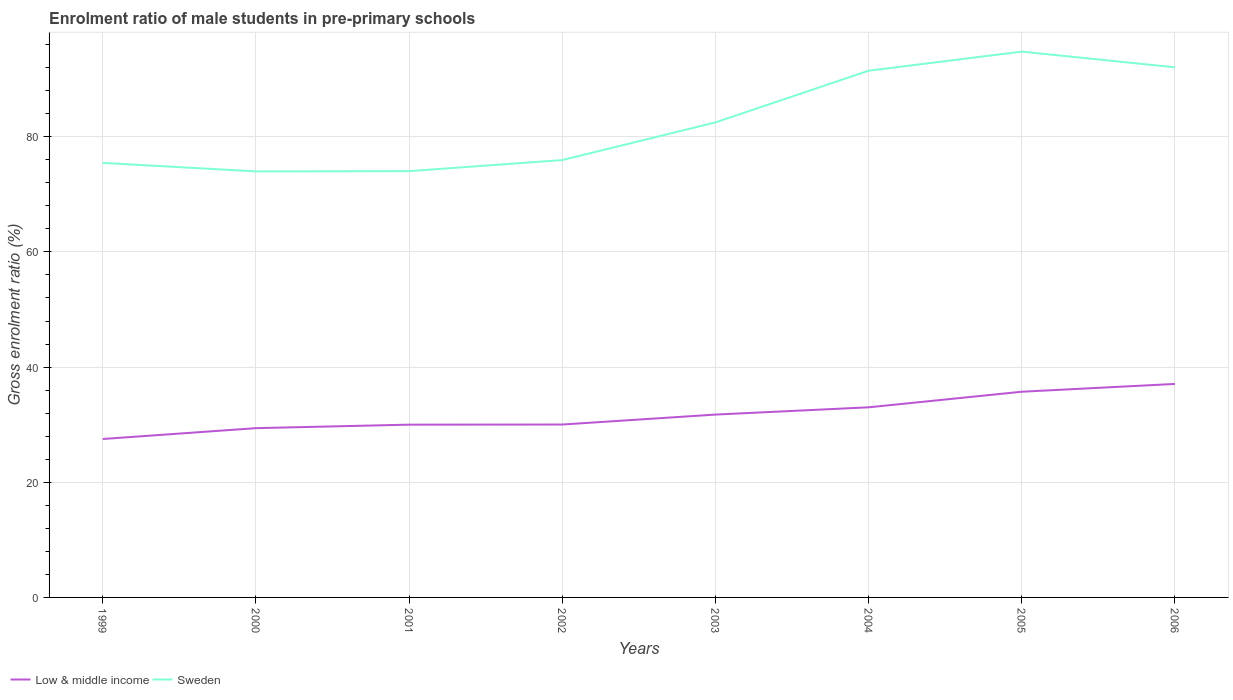Does the line corresponding to Sweden intersect with the line corresponding to Low & middle income?
Offer a terse response. No. Is the number of lines equal to the number of legend labels?
Offer a very short reply. Yes. Across all years, what is the maximum enrolment ratio of male students in pre-primary schools in Low & middle income?
Offer a very short reply. 27.51. What is the total enrolment ratio of male students in pre-primary schools in Low & middle income in the graph?
Your answer should be compact. -5.72. What is the difference between the highest and the second highest enrolment ratio of male students in pre-primary schools in Sweden?
Provide a succinct answer. 20.8. What is the difference between the highest and the lowest enrolment ratio of male students in pre-primary schools in Sweden?
Offer a terse response. 3. Is the enrolment ratio of male students in pre-primary schools in Low & middle income strictly greater than the enrolment ratio of male students in pre-primary schools in Sweden over the years?
Keep it short and to the point. Yes. How many lines are there?
Keep it short and to the point. 2. Are the values on the major ticks of Y-axis written in scientific E-notation?
Ensure brevity in your answer.  No. Does the graph contain any zero values?
Ensure brevity in your answer.  No. Does the graph contain grids?
Your answer should be very brief. Yes. Where does the legend appear in the graph?
Your answer should be very brief. Bottom left. How many legend labels are there?
Make the answer very short. 2. What is the title of the graph?
Provide a short and direct response. Enrolment ratio of male students in pre-primary schools. Does "Japan" appear as one of the legend labels in the graph?
Offer a terse response. No. What is the label or title of the X-axis?
Your answer should be very brief. Years. What is the label or title of the Y-axis?
Offer a terse response. Gross enrolment ratio (%). What is the Gross enrolment ratio (%) in Low & middle income in 1999?
Make the answer very short. 27.51. What is the Gross enrolment ratio (%) in Sweden in 1999?
Your answer should be very brief. 75.46. What is the Gross enrolment ratio (%) of Low & middle income in 2000?
Provide a succinct answer. 29.39. What is the Gross enrolment ratio (%) of Sweden in 2000?
Provide a short and direct response. 73.99. What is the Gross enrolment ratio (%) in Low & middle income in 2001?
Your answer should be compact. 30. What is the Gross enrolment ratio (%) in Sweden in 2001?
Provide a short and direct response. 74.02. What is the Gross enrolment ratio (%) of Low & middle income in 2002?
Give a very brief answer. 30.02. What is the Gross enrolment ratio (%) in Sweden in 2002?
Keep it short and to the point. 75.95. What is the Gross enrolment ratio (%) in Low & middle income in 2003?
Offer a very short reply. 31.75. What is the Gross enrolment ratio (%) of Sweden in 2003?
Your answer should be very brief. 82.49. What is the Gross enrolment ratio (%) of Low & middle income in 2004?
Make the answer very short. 33.01. What is the Gross enrolment ratio (%) of Sweden in 2004?
Your answer should be very brief. 91.47. What is the Gross enrolment ratio (%) in Low & middle income in 2005?
Your answer should be very brief. 35.72. What is the Gross enrolment ratio (%) in Sweden in 2005?
Keep it short and to the point. 94.78. What is the Gross enrolment ratio (%) of Low & middle income in 2006?
Give a very brief answer. 37.07. What is the Gross enrolment ratio (%) in Sweden in 2006?
Your response must be concise. 92.06. Across all years, what is the maximum Gross enrolment ratio (%) in Low & middle income?
Your answer should be very brief. 37.07. Across all years, what is the maximum Gross enrolment ratio (%) in Sweden?
Keep it short and to the point. 94.78. Across all years, what is the minimum Gross enrolment ratio (%) of Low & middle income?
Offer a terse response. 27.51. Across all years, what is the minimum Gross enrolment ratio (%) in Sweden?
Offer a terse response. 73.99. What is the total Gross enrolment ratio (%) in Low & middle income in the graph?
Provide a succinct answer. 254.49. What is the total Gross enrolment ratio (%) in Sweden in the graph?
Provide a succinct answer. 660.22. What is the difference between the Gross enrolment ratio (%) of Low & middle income in 1999 and that in 2000?
Offer a terse response. -1.88. What is the difference between the Gross enrolment ratio (%) in Sweden in 1999 and that in 2000?
Ensure brevity in your answer.  1.47. What is the difference between the Gross enrolment ratio (%) of Low & middle income in 1999 and that in 2001?
Make the answer very short. -2.49. What is the difference between the Gross enrolment ratio (%) of Sweden in 1999 and that in 2001?
Your response must be concise. 1.43. What is the difference between the Gross enrolment ratio (%) of Low & middle income in 1999 and that in 2002?
Provide a short and direct response. -2.51. What is the difference between the Gross enrolment ratio (%) of Sweden in 1999 and that in 2002?
Offer a very short reply. -0.49. What is the difference between the Gross enrolment ratio (%) in Low & middle income in 1999 and that in 2003?
Your answer should be compact. -4.24. What is the difference between the Gross enrolment ratio (%) of Sweden in 1999 and that in 2003?
Ensure brevity in your answer.  -7.03. What is the difference between the Gross enrolment ratio (%) of Low & middle income in 1999 and that in 2004?
Your answer should be compact. -5.5. What is the difference between the Gross enrolment ratio (%) in Sweden in 1999 and that in 2004?
Make the answer very short. -16.01. What is the difference between the Gross enrolment ratio (%) in Low & middle income in 1999 and that in 2005?
Your answer should be compact. -8.21. What is the difference between the Gross enrolment ratio (%) of Sweden in 1999 and that in 2005?
Give a very brief answer. -19.33. What is the difference between the Gross enrolment ratio (%) of Low & middle income in 1999 and that in 2006?
Your answer should be very brief. -9.56. What is the difference between the Gross enrolment ratio (%) of Sweden in 1999 and that in 2006?
Your response must be concise. -16.6. What is the difference between the Gross enrolment ratio (%) of Low & middle income in 2000 and that in 2001?
Ensure brevity in your answer.  -0.61. What is the difference between the Gross enrolment ratio (%) in Sweden in 2000 and that in 2001?
Your response must be concise. -0.04. What is the difference between the Gross enrolment ratio (%) in Low & middle income in 2000 and that in 2002?
Offer a very short reply. -0.63. What is the difference between the Gross enrolment ratio (%) in Sweden in 2000 and that in 2002?
Your response must be concise. -1.97. What is the difference between the Gross enrolment ratio (%) of Low & middle income in 2000 and that in 2003?
Your answer should be compact. -2.36. What is the difference between the Gross enrolment ratio (%) of Sweden in 2000 and that in 2003?
Your answer should be very brief. -8.5. What is the difference between the Gross enrolment ratio (%) in Low & middle income in 2000 and that in 2004?
Provide a short and direct response. -3.62. What is the difference between the Gross enrolment ratio (%) of Sweden in 2000 and that in 2004?
Provide a short and direct response. -17.48. What is the difference between the Gross enrolment ratio (%) in Low & middle income in 2000 and that in 2005?
Make the answer very short. -6.33. What is the difference between the Gross enrolment ratio (%) of Sweden in 2000 and that in 2005?
Provide a short and direct response. -20.8. What is the difference between the Gross enrolment ratio (%) in Low & middle income in 2000 and that in 2006?
Offer a terse response. -7.68. What is the difference between the Gross enrolment ratio (%) in Sweden in 2000 and that in 2006?
Give a very brief answer. -18.07. What is the difference between the Gross enrolment ratio (%) of Low & middle income in 2001 and that in 2002?
Provide a succinct answer. -0.02. What is the difference between the Gross enrolment ratio (%) of Sweden in 2001 and that in 2002?
Keep it short and to the point. -1.93. What is the difference between the Gross enrolment ratio (%) in Low & middle income in 2001 and that in 2003?
Offer a terse response. -1.75. What is the difference between the Gross enrolment ratio (%) in Sweden in 2001 and that in 2003?
Provide a short and direct response. -8.46. What is the difference between the Gross enrolment ratio (%) in Low & middle income in 2001 and that in 2004?
Provide a succinct answer. -3.01. What is the difference between the Gross enrolment ratio (%) in Sweden in 2001 and that in 2004?
Your answer should be compact. -17.44. What is the difference between the Gross enrolment ratio (%) of Low & middle income in 2001 and that in 2005?
Make the answer very short. -5.72. What is the difference between the Gross enrolment ratio (%) in Sweden in 2001 and that in 2005?
Offer a very short reply. -20.76. What is the difference between the Gross enrolment ratio (%) of Low & middle income in 2001 and that in 2006?
Your answer should be compact. -7.07. What is the difference between the Gross enrolment ratio (%) of Sweden in 2001 and that in 2006?
Your answer should be compact. -18.03. What is the difference between the Gross enrolment ratio (%) of Low & middle income in 2002 and that in 2003?
Provide a short and direct response. -1.73. What is the difference between the Gross enrolment ratio (%) in Sweden in 2002 and that in 2003?
Provide a succinct answer. -6.54. What is the difference between the Gross enrolment ratio (%) in Low & middle income in 2002 and that in 2004?
Offer a terse response. -2.99. What is the difference between the Gross enrolment ratio (%) in Sweden in 2002 and that in 2004?
Offer a very short reply. -15.51. What is the difference between the Gross enrolment ratio (%) of Low & middle income in 2002 and that in 2005?
Ensure brevity in your answer.  -5.7. What is the difference between the Gross enrolment ratio (%) in Sweden in 2002 and that in 2005?
Give a very brief answer. -18.83. What is the difference between the Gross enrolment ratio (%) in Low & middle income in 2002 and that in 2006?
Your answer should be very brief. -7.05. What is the difference between the Gross enrolment ratio (%) of Sweden in 2002 and that in 2006?
Give a very brief answer. -16.11. What is the difference between the Gross enrolment ratio (%) of Low & middle income in 2003 and that in 2004?
Provide a succinct answer. -1.26. What is the difference between the Gross enrolment ratio (%) in Sweden in 2003 and that in 2004?
Give a very brief answer. -8.98. What is the difference between the Gross enrolment ratio (%) of Low & middle income in 2003 and that in 2005?
Keep it short and to the point. -3.97. What is the difference between the Gross enrolment ratio (%) of Sweden in 2003 and that in 2005?
Your answer should be compact. -12.29. What is the difference between the Gross enrolment ratio (%) in Low & middle income in 2003 and that in 2006?
Your answer should be very brief. -5.32. What is the difference between the Gross enrolment ratio (%) of Sweden in 2003 and that in 2006?
Make the answer very short. -9.57. What is the difference between the Gross enrolment ratio (%) of Low & middle income in 2004 and that in 2005?
Your answer should be compact. -2.71. What is the difference between the Gross enrolment ratio (%) in Sweden in 2004 and that in 2005?
Offer a very short reply. -3.32. What is the difference between the Gross enrolment ratio (%) of Low & middle income in 2004 and that in 2006?
Offer a terse response. -4.06. What is the difference between the Gross enrolment ratio (%) of Sweden in 2004 and that in 2006?
Provide a succinct answer. -0.59. What is the difference between the Gross enrolment ratio (%) in Low & middle income in 2005 and that in 2006?
Keep it short and to the point. -1.35. What is the difference between the Gross enrolment ratio (%) in Sweden in 2005 and that in 2006?
Offer a terse response. 2.72. What is the difference between the Gross enrolment ratio (%) in Low & middle income in 1999 and the Gross enrolment ratio (%) in Sweden in 2000?
Provide a short and direct response. -46.48. What is the difference between the Gross enrolment ratio (%) in Low & middle income in 1999 and the Gross enrolment ratio (%) in Sweden in 2001?
Your response must be concise. -46.51. What is the difference between the Gross enrolment ratio (%) in Low & middle income in 1999 and the Gross enrolment ratio (%) in Sweden in 2002?
Your response must be concise. -48.44. What is the difference between the Gross enrolment ratio (%) in Low & middle income in 1999 and the Gross enrolment ratio (%) in Sweden in 2003?
Ensure brevity in your answer.  -54.98. What is the difference between the Gross enrolment ratio (%) in Low & middle income in 1999 and the Gross enrolment ratio (%) in Sweden in 2004?
Provide a succinct answer. -63.95. What is the difference between the Gross enrolment ratio (%) in Low & middle income in 1999 and the Gross enrolment ratio (%) in Sweden in 2005?
Offer a terse response. -67.27. What is the difference between the Gross enrolment ratio (%) in Low & middle income in 1999 and the Gross enrolment ratio (%) in Sweden in 2006?
Ensure brevity in your answer.  -64.55. What is the difference between the Gross enrolment ratio (%) of Low & middle income in 2000 and the Gross enrolment ratio (%) of Sweden in 2001?
Your answer should be very brief. -44.63. What is the difference between the Gross enrolment ratio (%) of Low & middle income in 2000 and the Gross enrolment ratio (%) of Sweden in 2002?
Your answer should be very brief. -46.56. What is the difference between the Gross enrolment ratio (%) of Low & middle income in 2000 and the Gross enrolment ratio (%) of Sweden in 2003?
Ensure brevity in your answer.  -53.09. What is the difference between the Gross enrolment ratio (%) of Low & middle income in 2000 and the Gross enrolment ratio (%) of Sweden in 2004?
Your answer should be compact. -62.07. What is the difference between the Gross enrolment ratio (%) of Low & middle income in 2000 and the Gross enrolment ratio (%) of Sweden in 2005?
Ensure brevity in your answer.  -65.39. What is the difference between the Gross enrolment ratio (%) in Low & middle income in 2000 and the Gross enrolment ratio (%) in Sweden in 2006?
Provide a short and direct response. -62.66. What is the difference between the Gross enrolment ratio (%) in Low & middle income in 2001 and the Gross enrolment ratio (%) in Sweden in 2002?
Offer a terse response. -45.95. What is the difference between the Gross enrolment ratio (%) in Low & middle income in 2001 and the Gross enrolment ratio (%) in Sweden in 2003?
Your answer should be compact. -52.49. What is the difference between the Gross enrolment ratio (%) of Low & middle income in 2001 and the Gross enrolment ratio (%) of Sweden in 2004?
Offer a very short reply. -61.46. What is the difference between the Gross enrolment ratio (%) in Low & middle income in 2001 and the Gross enrolment ratio (%) in Sweden in 2005?
Keep it short and to the point. -64.78. What is the difference between the Gross enrolment ratio (%) of Low & middle income in 2001 and the Gross enrolment ratio (%) of Sweden in 2006?
Offer a very short reply. -62.06. What is the difference between the Gross enrolment ratio (%) in Low & middle income in 2002 and the Gross enrolment ratio (%) in Sweden in 2003?
Your answer should be compact. -52.46. What is the difference between the Gross enrolment ratio (%) of Low & middle income in 2002 and the Gross enrolment ratio (%) of Sweden in 2004?
Your answer should be very brief. -61.44. What is the difference between the Gross enrolment ratio (%) in Low & middle income in 2002 and the Gross enrolment ratio (%) in Sweden in 2005?
Provide a short and direct response. -64.76. What is the difference between the Gross enrolment ratio (%) of Low & middle income in 2002 and the Gross enrolment ratio (%) of Sweden in 2006?
Provide a succinct answer. -62.04. What is the difference between the Gross enrolment ratio (%) in Low & middle income in 2003 and the Gross enrolment ratio (%) in Sweden in 2004?
Your response must be concise. -59.71. What is the difference between the Gross enrolment ratio (%) of Low & middle income in 2003 and the Gross enrolment ratio (%) of Sweden in 2005?
Offer a terse response. -63.03. What is the difference between the Gross enrolment ratio (%) in Low & middle income in 2003 and the Gross enrolment ratio (%) in Sweden in 2006?
Offer a terse response. -60.31. What is the difference between the Gross enrolment ratio (%) of Low & middle income in 2004 and the Gross enrolment ratio (%) of Sweden in 2005?
Provide a short and direct response. -61.77. What is the difference between the Gross enrolment ratio (%) in Low & middle income in 2004 and the Gross enrolment ratio (%) in Sweden in 2006?
Offer a very short reply. -59.05. What is the difference between the Gross enrolment ratio (%) of Low & middle income in 2005 and the Gross enrolment ratio (%) of Sweden in 2006?
Your response must be concise. -56.34. What is the average Gross enrolment ratio (%) of Low & middle income per year?
Keep it short and to the point. 31.81. What is the average Gross enrolment ratio (%) of Sweden per year?
Ensure brevity in your answer.  82.53. In the year 1999, what is the difference between the Gross enrolment ratio (%) of Low & middle income and Gross enrolment ratio (%) of Sweden?
Give a very brief answer. -47.95. In the year 2000, what is the difference between the Gross enrolment ratio (%) of Low & middle income and Gross enrolment ratio (%) of Sweden?
Your answer should be compact. -44.59. In the year 2001, what is the difference between the Gross enrolment ratio (%) in Low & middle income and Gross enrolment ratio (%) in Sweden?
Give a very brief answer. -44.02. In the year 2002, what is the difference between the Gross enrolment ratio (%) in Low & middle income and Gross enrolment ratio (%) in Sweden?
Provide a short and direct response. -45.93. In the year 2003, what is the difference between the Gross enrolment ratio (%) in Low & middle income and Gross enrolment ratio (%) in Sweden?
Provide a succinct answer. -50.74. In the year 2004, what is the difference between the Gross enrolment ratio (%) in Low & middle income and Gross enrolment ratio (%) in Sweden?
Make the answer very short. -58.45. In the year 2005, what is the difference between the Gross enrolment ratio (%) in Low & middle income and Gross enrolment ratio (%) in Sweden?
Make the answer very short. -59.06. In the year 2006, what is the difference between the Gross enrolment ratio (%) of Low & middle income and Gross enrolment ratio (%) of Sweden?
Make the answer very short. -54.99. What is the ratio of the Gross enrolment ratio (%) of Low & middle income in 1999 to that in 2000?
Keep it short and to the point. 0.94. What is the ratio of the Gross enrolment ratio (%) of Sweden in 1999 to that in 2000?
Your response must be concise. 1.02. What is the ratio of the Gross enrolment ratio (%) of Low & middle income in 1999 to that in 2001?
Offer a very short reply. 0.92. What is the ratio of the Gross enrolment ratio (%) in Sweden in 1999 to that in 2001?
Offer a very short reply. 1.02. What is the ratio of the Gross enrolment ratio (%) in Low & middle income in 1999 to that in 2002?
Your answer should be very brief. 0.92. What is the ratio of the Gross enrolment ratio (%) of Sweden in 1999 to that in 2002?
Provide a short and direct response. 0.99. What is the ratio of the Gross enrolment ratio (%) in Low & middle income in 1999 to that in 2003?
Ensure brevity in your answer.  0.87. What is the ratio of the Gross enrolment ratio (%) of Sweden in 1999 to that in 2003?
Your response must be concise. 0.91. What is the ratio of the Gross enrolment ratio (%) in Low & middle income in 1999 to that in 2004?
Give a very brief answer. 0.83. What is the ratio of the Gross enrolment ratio (%) of Sweden in 1999 to that in 2004?
Ensure brevity in your answer.  0.82. What is the ratio of the Gross enrolment ratio (%) of Low & middle income in 1999 to that in 2005?
Keep it short and to the point. 0.77. What is the ratio of the Gross enrolment ratio (%) in Sweden in 1999 to that in 2005?
Ensure brevity in your answer.  0.8. What is the ratio of the Gross enrolment ratio (%) of Low & middle income in 1999 to that in 2006?
Give a very brief answer. 0.74. What is the ratio of the Gross enrolment ratio (%) of Sweden in 1999 to that in 2006?
Keep it short and to the point. 0.82. What is the ratio of the Gross enrolment ratio (%) of Low & middle income in 2000 to that in 2001?
Provide a succinct answer. 0.98. What is the ratio of the Gross enrolment ratio (%) of Low & middle income in 2000 to that in 2002?
Offer a very short reply. 0.98. What is the ratio of the Gross enrolment ratio (%) of Sweden in 2000 to that in 2002?
Give a very brief answer. 0.97. What is the ratio of the Gross enrolment ratio (%) in Low & middle income in 2000 to that in 2003?
Provide a succinct answer. 0.93. What is the ratio of the Gross enrolment ratio (%) in Sweden in 2000 to that in 2003?
Provide a succinct answer. 0.9. What is the ratio of the Gross enrolment ratio (%) of Low & middle income in 2000 to that in 2004?
Ensure brevity in your answer.  0.89. What is the ratio of the Gross enrolment ratio (%) of Sweden in 2000 to that in 2004?
Your answer should be very brief. 0.81. What is the ratio of the Gross enrolment ratio (%) in Low & middle income in 2000 to that in 2005?
Offer a very short reply. 0.82. What is the ratio of the Gross enrolment ratio (%) of Sweden in 2000 to that in 2005?
Your answer should be compact. 0.78. What is the ratio of the Gross enrolment ratio (%) in Low & middle income in 2000 to that in 2006?
Your answer should be compact. 0.79. What is the ratio of the Gross enrolment ratio (%) of Sweden in 2000 to that in 2006?
Offer a terse response. 0.8. What is the ratio of the Gross enrolment ratio (%) in Sweden in 2001 to that in 2002?
Your answer should be very brief. 0.97. What is the ratio of the Gross enrolment ratio (%) of Low & middle income in 2001 to that in 2003?
Your response must be concise. 0.94. What is the ratio of the Gross enrolment ratio (%) of Sweden in 2001 to that in 2003?
Offer a terse response. 0.9. What is the ratio of the Gross enrolment ratio (%) of Low & middle income in 2001 to that in 2004?
Give a very brief answer. 0.91. What is the ratio of the Gross enrolment ratio (%) in Sweden in 2001 to that in 2004?
Your response must be concise. 0.81. What is the ratio of the Gross enrolment ratio (%) in Low & middle income in 2001 to that in 2005?
Your answer should be compact. 0.84. What is the ratio of the Gross enrolment ratio (%) of Sweden in 2001 to that in 2005?
Offer a very short reply. 0.78. What is the ratio of the Gross enrolment ratio (%) in Low & middle income in 2001 to that in 2006?
Your answer should be very brief. 0.81. What is the ratio of the Gross enrolment ratio (%) in Sweden in 2001 to that in 2006?
Make the answer very short. 0.8. What is the ratio of the Gross enrolment ratio (%) of Low & middle income in 2002 to that in 2003?
Offer a very short reply. 0.95. What is the ratio of the Gross enrolment ratio (%) of Sweden in 2002 to that in 2003?
Your answer should be compact. 0.92. What is the ratio of the Gross enrolment ratio (%) in Low & middle income in 2002 to that in 2004?
Your answer should be compact. 0.91. What is the ratio of the Gross enrolment ratio (%) of Sweden in 2002 to that in 2004?
Your answer should be compact. 0.83. What is the ratio of the Gross enrolment ratio (%) of Low & middle income in 2002 to that in 2005?
Offer a terse response. 0.84. What is the ratio of the Gross enrolment ratio (%) in Sweden in 2002 to that in 2005?
Keep it short and to the point. 0.8. What is the ratio of the Gross enrolment ratio (%) of Low & middle income in 2002 to that in 2006?
Give a very brief answer. 0.81. What is the ratio of the Gross enrolment ratio (%) in Sweden in 2002 to that in 2006?
Ensure brevity in your answer.  0.82. What is the ratio of the Gross enrolment ratio (%) in Low & middle income in 2003 to that in 2004?
Give a very brief answer. 0.96. What is the ratio of the Gross enrolment ratio (%) in Sweden in 2003 to that in 2004?
Give a very brief answer. 0.9. What is the ratio of the Gross enrolment ratio (%) of Sweden in 2003 to that in 2005?
Make the answer very short. 0.87. What is the ratio of the Gross enrolment ratio (%) of Low & middle income in 2003 to that in 2006?
Give a very brief answer. 0.86. What is the ratio of the Gross enrolment ratio (%) of Sweden in 2003 to that in 2006?
Provide a succinct answer. 0.9. What is the ratio of the Gross enrolment ratio (%) of Low & middle income in 2004 to that in 2005?
Keep it short and to the point. 0.92. What is the ratio of the Gross enrolment ratio (%) in Sweden in 2004 to that in 2005?
Ensure brevity in your answer.  0.96. What is the ratio of the Gross enrolment ratio (%) of Low & middle income in 2004 to that in 2006?
Your answer should be compact. 0.89. What is the ratio of the Gross enrolment ratio (%) of Low & middle income in 2005 to that in 2006?
Your answer should be very brief. 0.96. What is the ratio of the Gross enrolment ratio (%) of Sweden in 2005 to that in 2006?
Your answer should be compact. 1.03. What is the difference between the highest and the second highest Gross enrolment ratio (%) of Low & middle income?
Your response must be concise. 1.35. What is the difference between the highest and the second highest Gross enrolment ratio (%) of Sweden?
Provide a short and direct response. 2.72. What is the difference between the highest and the lowest Gross enrolment ratio (%) of Low & middle income?
Your answer should be compact. 9.56. What is the difference between the highest and the lowest Gross enrolment ratio (%) of Sweden?
Offer a very short reply. 20.8. 